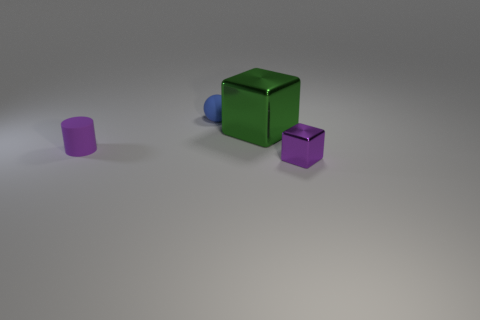There is a metallic object that is behind the tiny object that is in front of the purple matte cylinder; how many cylinders are in front of it?
Ensure brevity in your answer.  1. How many purple objects are tiny metallic objects or matte objects?
Your answer should be compact. 2. There is a thing to the left of the ball; what shape is it?
Your answer should be very brief. Cylinder. The matte sphere that is the same size as the purple metallic block is what color?
Offer a terse response. Blue. Do the green shiny thing and the tiny purple object right of the tiny blue object have the same shape?
Provide a succinct answer. Yes. There is a small thing behind the purple thing to the left of the small purple object to the right of the green block; what is its material?
Provide a short and direct response. Rubber. How many large objects are either brown metal blocks or metallic things?
Provide a succinct answer. 1. How many other things are the same size as the purple cylinder?
Keep it short and to the point. 2. There is a small metallic thing to the right of the small blue matte ball; is it the same shape as the large green shiny object?
Give a very brief answer. Yes. There is a big object that is the same shape as the small purple shiny thing; what is its color?
Provide a succinct answer. Green. 